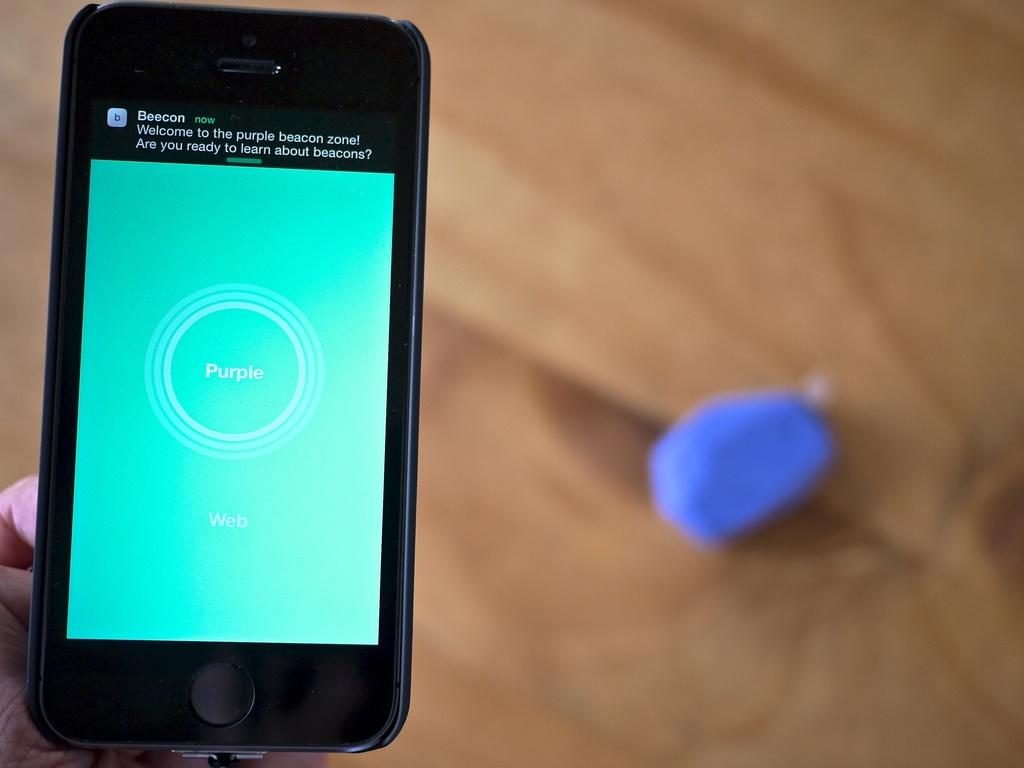What electronic device is visible in the image? There is a smartphone in the image. Can you describe the background of the image? The background of the image is blurry. What type of light source can be seen illuminating the cat in the market in the image? There is no cat or market present in the image, and therefore no such light source can be observed. 